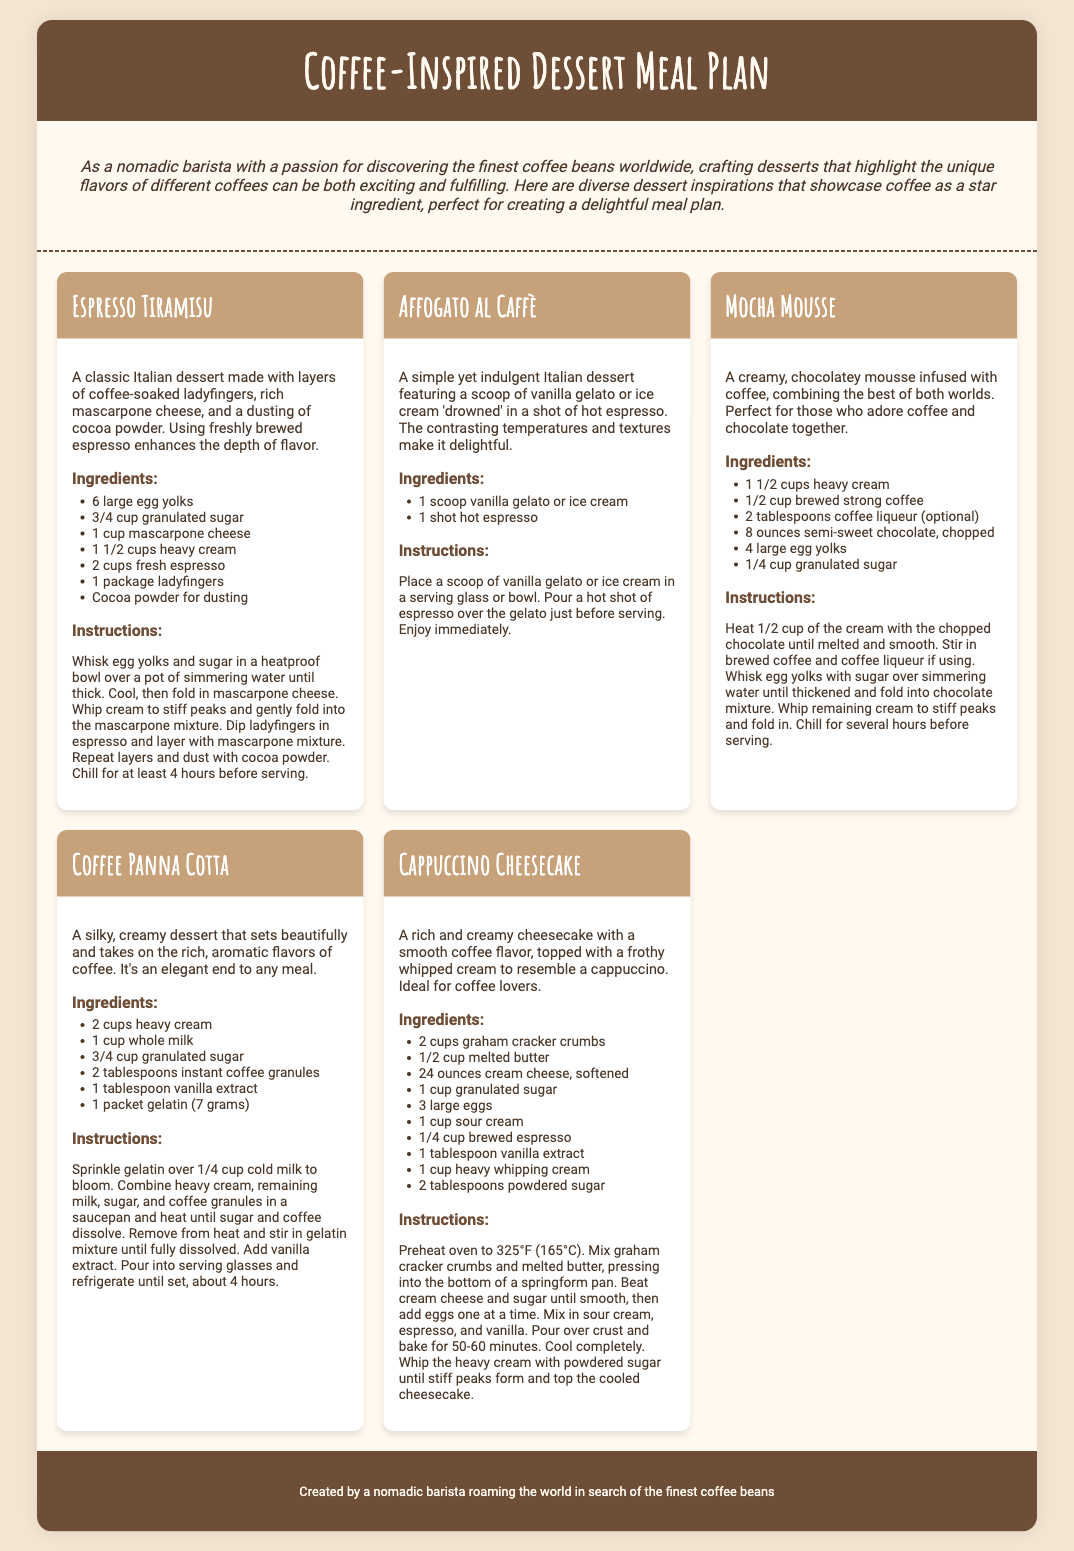What is the title of the document? The title of the document is displayed at the top header section, specifying the theme of the content.
Answer: Coffee-Inspired Dessert Meal Plan How many ingredients are listed for Espresso Tiramisu? The number of ingredients for Espresso Tiramisu is counted in the ingredients section of that dessert card.
Answer: 7 What dessert features a scoop of vanilla gelato? This dessert is described in its content with the main ingredient being vanilla gelato.
Answer: Affogato al Caffè Which dessert requires gelatin in the ingredients? The presence of gelatin is specific to one dessert listed, which can be identified in the ingredients section.
Answer: Coffee Panna Cotta How long should the Espresso Tiramisu be chilled before serving? This time is mentioned in the instructions section specific to the Espresso Tiramisu.
Answer: 4 hours What is the main flavor that Mocha Mousse combines? This flavor combination is highlighted in the dessert description.
Answer: Coffee and chocolate What is used for dusting in Espresso Tiramisu? The detail about the topping for the dessert can be found in the description.
Answer: Cocoa powder How many egg yolks are needed for Cappuccino Cheesecake? The required number of egg yolks is listed in the ingredients section for that specific dessert.
Answer: 3 